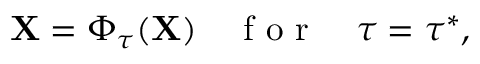<formula> <loc_0><loc_0><loc_500><loc_500>X = \Phi _ { \tau } ( X ) \quad f o r \quad \tau = \tau ^ { * } ,</formula> 